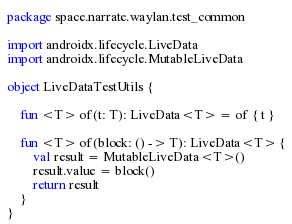Convert code to text. <code><loc_0><loc_0><loc_500><loc_500><_Kotlin_>package space.narrate.waylan.test_common

import androidx.lifecycle.LiveData
import androidx.lifecycle.MutableLiveData

object LiveDataTestUtils {

    fun <T> of(t: T): LiveData<T> = of { t }

    fun <T> of(block: () -> T): LiveData<T> {
        val result = MutableLiveData<T>()
        result.value = block()
        return result
    }
}</code> 